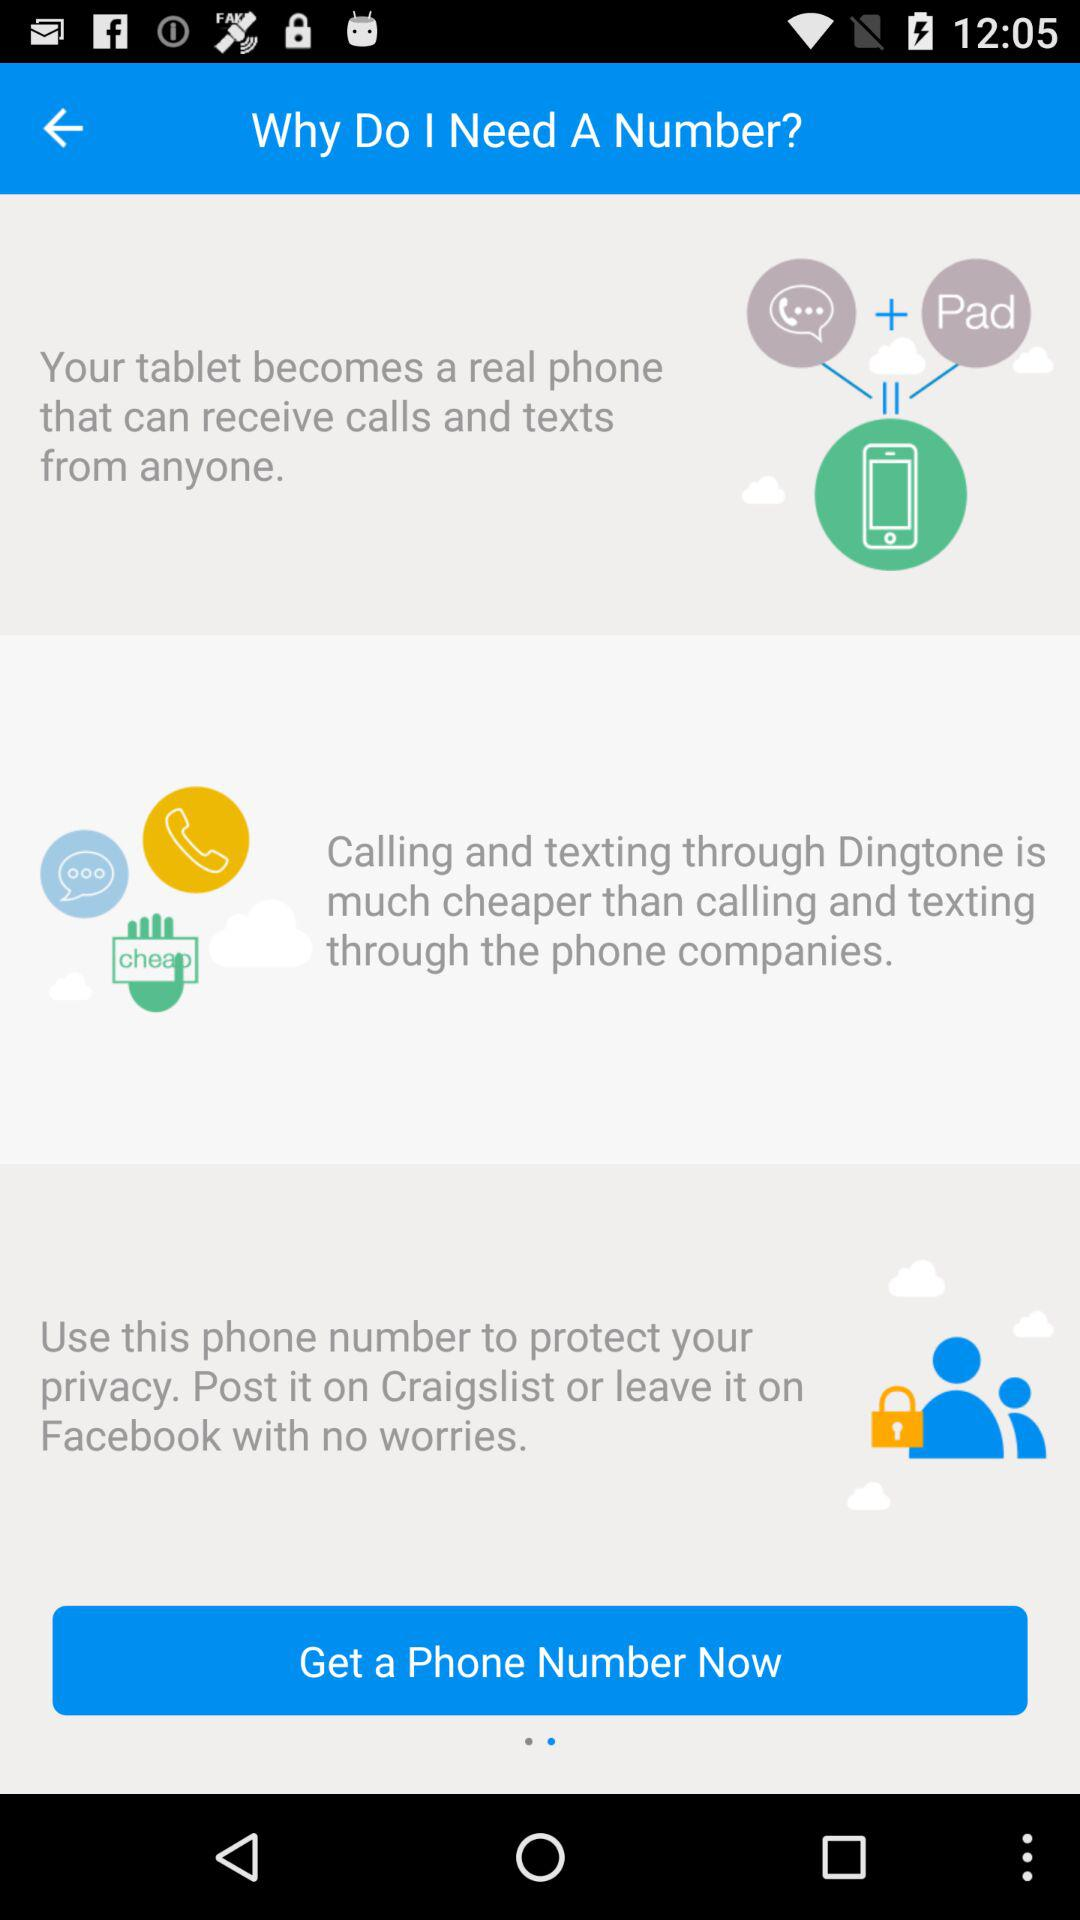How many unread notifications are there?
When the provided information is insufficient, respond with <no answer>. <no answer> 